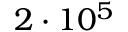<formula> <loc_0><loc_0><loc_500><loc_500>2 \cdot 1 0 ^ { 5 }</formula> 